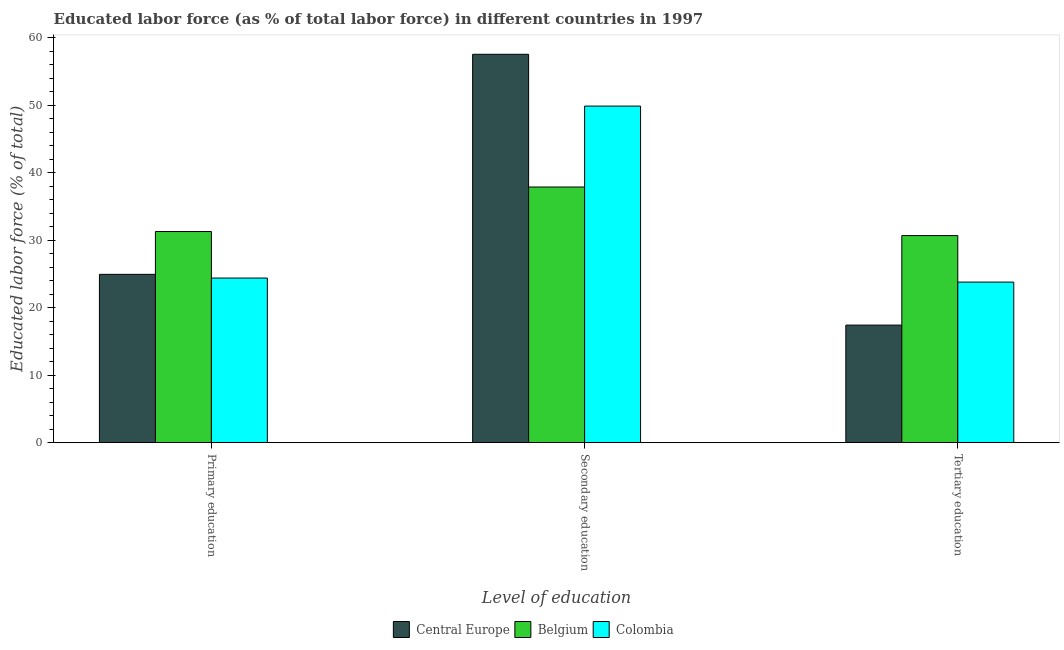How many groups of bars are there?
Keep it short and to the point. 3. Are the number of bars per tick equal to the number of legend labels?
Offer a very short reply. Yes. How many bars are there on the 3rd tick from the right?
Make the answer very short. 3. What is the percentage of labor force who received tertiary education in Colombia?
Your response must be concise. 23.8. Across all countries, what is the maximum percentage of labor force who received secondary education?
Keep it short and to the point. 57.58. Across all countries, what is the minimum percentage of labor force who received tertiary education?
Your answer should be compact. 17.42. In which country was the percentage of labor force who received tertiary education maximum?
Provide a succinct answer. Belgium. What is the total percentage of labor force who received tertiary education in the graph?
Make the answer very short. 71.92. What is the difference between the percentage of labor force who received tertiary education in Central Europe and that in Belgium?
Your answer should be compact. -13.28. What is the difference between the percentage of labor force who received primary education in Colombia and the percentage of labor force who received tertiary education in Central Europe?
Ensure brevity in your answer.  6.98. What is the average percentage of labor force who received primary education per country?
Keep it short and to the point. 26.88. What is the difference between the percentage of labor force who received tertiary education and percentage of labor force who received secondary education in Belgium?
Give a very brief answer. -7.2. In how many countries, is the percentage of labor force who received tertiary education greater than 58 %?
Your answer should be compact. 0. What is the ratio of the percentage of labor force who received tertiary education in Central Europe to that in Belgium?
Provide a short and direct response. 0.57. Is the percentage of labor force who received tertiary education in Belgium less than that in Central Europe?
Offer a terse response. No. What is the difference between the highest and the second highest percentage of labor force who received secondary education?
Your answer should be compact. 7.68. What is the difference between the highest and the lowest percentage of labor force who received secondary education?
Provide a succinct answer. 19.68. Is the sum of the percentage of labor force who received primary education in Central Europe and Colombia greater than the maximum percentage of labor force who received tertiary education across all countries?
Offer a terse response. Yes. What does the 1st bar from the left in Tertiary education represents?
Make the answer very short. Central Europe. What does the 2nd bar from the right in Tertiary education represents?
Your answer should be compact. Belgium. Are all the bars in the graph horizontal?
Your response must be concise. No. What is the difference between two consecutive major ticks on the Y-axis?
Provide a succinct answer. 10. Are the values on the major ticks of Y-axis written in scientific E-notation?
Provide a short and direct response. No. Does the graph contain any zero values?
Make the answer very short. No. Does the graph contain grids?
Your answer should be compact. No. Where does the legend appear in the graph?
Provide a short and direct response. Bottom center. How are the legend labels stacked?
Your response must be concise. Horizontal. What is the title of the graph?
Ensure brevity in your answer.  Educated labor force (as % of total labor force) in different countries in 1997. What is the label or title of the X-axis?
Give a very brief answer. Level of education. What is the label or title of the Y-axis?
Your response must be concise. Educated labor force (% of total). What is the Educated labor force (% of total) of Central Europe in Primary education?
Your response must be concise. 24.95. What is the Educated labor force (% of total) of Belgium in Primary education?
Your response must be concise. 31.3. What is the Educated labor force (% of total) of Colombia in Primary education?
Ensure brevity in your answer.  24.4. What is the Educated labor force (% of total) of Central Europe in Secondary education?
Provide a short and direct response. 57.58. What is the Educated labor force (% of total) in Belgium in Secondary education?
Your response must be concise. 37.9. What is the Educated labor force (% of total) of Colombia in Secondary education?
Offer a very short reply. 49.9. What is the Educated labor force (% of total) in Central Europe in Tertiary education?
Offer a very short reply. 17.42. What is the Educated labor force (% of total) of Belgium in Tertiary education?
Offer a very short reply. 30.7. What is the Educated labor force (% of total) in Colombia in Tertiary education?
Your response must be concise. 23.8. Across all Level of education, what is the maximum Educated labor force (% of total) of Central Europe?
Offer a very short reply. 57.58. Across all Level of education, what is the maximum Educated labor force (% of total) in Belgium?
Provide a succinct answer. 37.9. Across all Level of education, what is the maximum Educated labor force (% of total) in Colombia?
Provide a short and direct response. 49.9. Across all Level of education, what is the minimum Educated labor force (% of total) in Central Europe?
Offer a very short reply. 17.42. Across all Level of education, what is the minimum Educated labor force (% of total) in Belgium?
Give a very brief answer. 30.7. Across all Level of education, what is the minimum Educated labor force (% of total) in Colombia?
Offer a very short reply. 23.8. What is the total Educated labor force (% of total) of Central Europe in the graph?
Ensure brevity in your answer.  99.95. What is the total Educated labor force (% of total) in Belgium in the graph?
Make the answer very short. 99.9. What is the total Educated labor force (% of total) in Colombia in the graph?
Offer a very short reply. 98.1. What is the difference between the Educated labor force (% of total) of Central Europe in Primary education and that in Secondary education?
Your answer should be very brief. -32.63. What is the difference between the Educated labor force (% of total) in Colombia in Primary education and that in Secondary education?
Your response must be concise. -25.5. What is the difference between the Educated labor force (% of total) of Central Europe in Primary education and that in Tertiary education?
Your answer should be very brief. 7.53. What is the difference between the Educated labor force (% of total) in Belgium in Primary education and that in Tertiary education?
Your response must be concise. 0.6. What is the difference between the Educated labor force (% of total) of Central Europe in Secondary education and that in Tertiary education?
Offer a terse response. 40.16. What is the difference between the Educated labor force (% of total) of Belgium in Secondary education and that in Tertiary education?
Make the answer very short. 7.2. What is the difference between the Educated labor force (% of total) in Colombia in Secondary education and that in Tertiary education?
Ensure brevity in your answer.  26.1. What is the difference between the Educated labor force (% of total) in Central Europe in Primary education and the Educated labor force (% of total) in Belgium in Secondary education?
Offer a very short reply. -12.95. What is the difference between the Educated labor force (% of total) of Central Europe in Primary education and the Educated labor force (% of total) of Colombia in Secondary education?
Provide a succinct answer. -24.95. What is the difference between the Educated labor force (% of total) of Belgium in Primary education and the Educated labor force (% of total) of Colombia in Secondary education?
Make the answer very short. -18.6. What is the difference between the Educated labor force (% of total) in Central Europe in Primary education and the Educated labor force (% of total) in Belgium in Tertiary education?
Your answer should be very brief. -5.75. What is the difference between the Educated labor force (% of total) in Central Europe in Primary education and the Educated labor force (% of total) in Colombia in Tertiary education?
Provide a succinct answer. 1.15. What is the difference between the Educated labor force (% of total) in Central Europe in Secondary education and the Educated labor force (% of total) in Belgium in Tertiary education?
Ensure brevity in your answer.  26.88. What is the difference between the Educated labor force (% of total) in Central Europe in Secondary education and the Educated labor force (% of total) in Colombia in Tertiary education?
Offer a terse response. 33.78. What is the difference between the Educated labor force (% of total) of Belgium in Secondary education and the Educated labor force (% of total) of Colombia in Tertiary education?
Keep it short and to the point. 14.1. What is the average Educated labor force (% of total) in Central Europe per Level of education?
Provide a succinct answer. 33.32. What is the average Educated labor force (% of total) in Belgium per Level of education?
Keep it short and to the point. 33.3. What is the average Educated labor force (% of total) of Colombia per Level of education?
Your answer should be compact. 32.7. What is the difference between the Educated labor force (% of total) of Central Europe and Educated labor force (% of total) of Belgium in Primary education?
Offer a very short reply. -6.35. What is the difference between the Educated labor force (% of total) of Central Europe and Educated labor force (% of total) of Colombia in Primary education?
Keep it short and to the point. 0.55. What is the difference between the Educated labor force (% of total) in Central Europe and Educated labor force (% of total) in Belgium in Secondary education?
Offer a very short reply. 19.68. What is the difference between the Educated labor force (% of total) of Central Europe and Educated labor force (% of total) of Colombia in Secondary education?
Your answer should be very brief. 7.68. What is the difference between the Educated labor force (% of total) of Belgium and Educated labor force (% of total) of Colombia in Secondary education?
Ensure brevity in your answer.  -12. What is the difference between the Educated labor force (% of total) of Central Europe and Educated labor force (% of total) of Belgium in Tertiary education?
Your response must be concise. -13.28. What is the difference between the Educated labor force (% of total) in Central Europe and Educated labor force (% of total) in Colombia in Tertiary education?
Make the answer very short. -6.38. What is the difference between the Educated labor force (% of total) in Belgium and Educated labor force (% of total) in Colombia in Tertiary education?
Offer a terse response. 6.9. What is the ratio of the Educated labor force (% of total) of Central Europe in Primary education to that in Secondary education?
Offer a terse response. 0.43. What is the ratio of the Educated labor force (% of total) in Belgium in Primary education to that in Secondary education?
Ensure brevity in your answer.  0.83. What is the ratio of the Educated labor force (% of total) in Colombia in Primary education to that in Secondary education?
Make the answer very short. 0.49. What is the ratio of the Educated labor force (% of total) of Central Europe in Primary education to that in Tertiary education?
Offer a terse response. 1.43. What is the ratio of the Educated labor force (% of total) in Belgium in Primary education to that in Tertiary education?
Provide a short and direct response. 1.02. What is the ratio of the Educated labor force (% of total) of Colombia in Primary education to that in Tertiary education?
Your answer should be compact. 1.03. What is the ratio of the Educated labor force (% of total) in Central Europe in Secondary education to that in Tertiary education?
Make the answer very short. 3.3. What is the ratio of the Educated labor force (% of total) in Belgium in Secondary education to that in Tertiary education?
Make the answer very short. 1.23. What is the ratio of the Educated labor force (% of total) of Colombia in Secondary education to that in Tertiary education?
Offer a very short reply. 2.1. What is the difference between the highest and the second highest Educated labor force (% of total) of Central Europe?
Ensure brevity in your answer.  32.63. What is the difference between the highest and the second highest Educated labor force (% of total) of Colombia?
Provide a succinct answer. 25.5. What is the difference between the highest and the lowest Educated labor force (% of total) of Central Europe?
Keep it short and to the point. 40.16. What is the difference between the highest and the lowest Educated labor force (% of total) in Colombia?
Offer a very short reply. 26.1. 